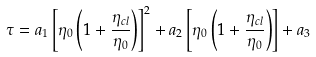<formula> <loc_0><loc_0><loc_500><loc_500>\tau = a _ { 1 } \left [ \eta _ { 0 } \left ( 1 + \frac { \eta _ { c l } } { \eta _ { 0 } } \right ) \right ] ^ { 2 } + a _ { 2 } \left [ \eta _ { 0 } \left ( 1 + \frac { \eta _ { c l } } { \eta _ { 0 } } \right ) \right ] + a _ { 3 }</formula> 